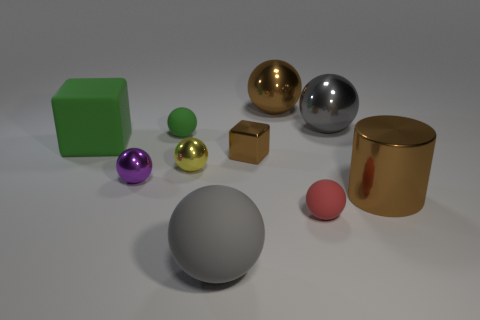Subtract all yellow spheres. How many spheres are left? 6 Subtract all green cubes. How many cubes are left? 1 Subtract 2 blocks. How many blocks are left? 0 Subtract 0 yellow blocks. How many objects are left? 10 Subtract all cylinders. How many objects are left? 9 Subtract all blue cubes. Subtract all brown balls. How many cubes are left? 2 Subtract all yellow cubes. How many red cylinders are left? 0 Subtract all green metal cylinders. Subtract all big matte things. How many objects are left? 8 Add 9 metallic cubes. How many metallic cubes are left? 10 Add 1 green things. How many green things exist? 3 